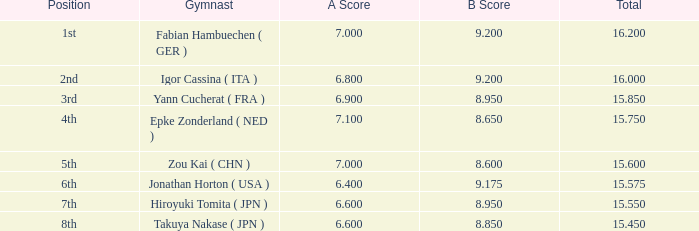What was the overall rating with a score exceeding 7 and a b score less than 8.65? None. 